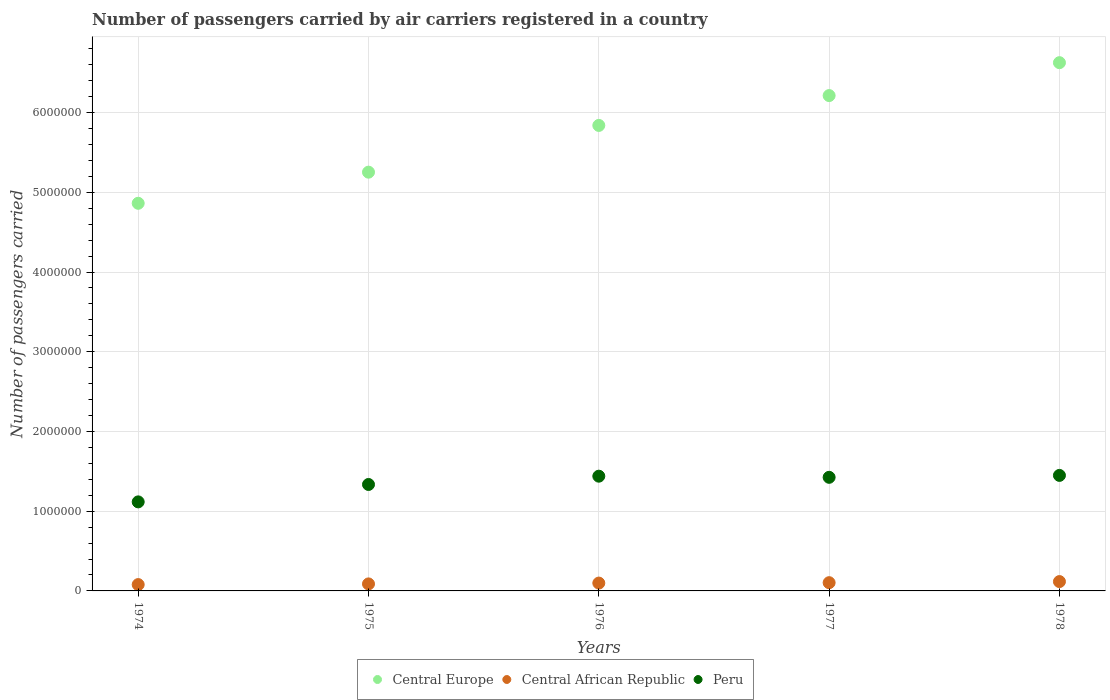How many different coloured dotlines are there?
Make the answer very short. 3. Is the number of dotlines equal to the number of legend labels?
Your response must be concise. Yes. What is the number of passengers carried by air carriers in Central Europe in 1976?
Provide a succinct answer. 5.84e+06. Across all years, what is the maximum number of passengers carried by air carriers in Central Europe?
Your answer should be compact. 6.63e+06. Across all years, what is the minimum number of passengers carried by air carriers in Central Europe?
Provide a succinct answer. 4.86e+06. In which year was the number of passengers carried by air carriers in Central African Republic maximum?
Make the answer very short. 1978. In which year was the number of passengers carried by air carriers in Peru minimum?
Provide a short and direct response. 1974. What is the total number of passengers carried by air carriers in Central African Republic in the graph?
Make the answer very short. 4.86e+05. What is the difference between the number of passengers carried by air carriers in Central Europe in 1976 and that in 1978?
Provide a short and direct response. -7.87e+05. What is the difference between the number of passengers carried by air carriers in Peru in 1975 and the number of passengers carried by air carriers in Central African Republic in 1978?
Your response must be concise. 1.22e+06. What is the average number of passengers carried by air carriers in Peru per year?
Make the answer very short. 1.35e+06. In the year 1977, what is the difference between the number of passengers carried by air carriers in Central Europe and number of passengers carried by air carriers in Peru?
Your response must be concise. 4.79e+06. What is the ratio of the number of passengers carried by air carriers in Central Europe in 1975 to that in 1978?
Ensure brevity in your answer.  0.79. Is the number of passengers carried by air carriers in Peru in 1974 less than that in 1977?
Offer a very short reply. Yes. Is the difference between the number of passengers carried by air carriers in Central Europe in 1975 and 1978 greater than the difference between the number of passengers carried by air carriers in Peru in 1975 and 1978?
Give a very brief answer. No. What is the difference between the highest and the second highest number of passengers carried by air carriers in Central Europe?
Offer a very short reply. 4.13e+05. What is the difference between the highest and the lowest number of passengers carried by air carriers in Peru?
Offer a very short reply. 3.32e+05. In how many years, is the number of passengers carried by air carriers in Central Europe greater than the average number of passengers carried by air carriers in Central Europe taken over all years?
Offer a terse response. 3. Is the sum of the number of passengers carried by air carriers in Peru in 1976 and 1978 greater than the maximum number of passengers carried by air carriers in Central Europe across all years?
Make the answer very short. No. Is it the case that in every year, the sum of the number of passengers carried by air carriers in Central Europe and number of passengers carried by air carriers in Central African Republic  is greater than the number of passengers carried by air carriers in Peru?
Your answer should be compact. Yes. Does the number of passengers carried by air carriers in Central African Republic monotonically increase over the years?
Your answer should be compact. Yes. Is the number of passengers carried by air carriers in Central Europe strictly less than the number of passengers carried by air carriers in Central African Republic over the years?
Give a very brief answer. No. How many dotlines are there?
Provide a succinct answer. 3. What is the difference between two consecutive major ticks on the Y-axis?
Your response must be concise. 1.00e+06. Are the values on the major ticks of Y-axis written in scientific E-notation?
Keep it short and to the point. No. Does the graph contain any zero values?
Your response must be concise. No. Where does the legend appear in the graph?
Provide a short and direct response. Bottom center. How many legend labels are there?
Offer a terse response. 3. What is the title of the graph?
Ensure brevity in your answer.  Number of passengers carried by air carriers registered in a country. Does "Chile" appear as one of the legend labels in the graph?
Provide a succinct answer. No. What is the label or title of the X-axis?
Your response must be concise. Years. What is the label or title of the Y-axis?
Give a very brief answer. Number of passengers carried. What is the Number of passengers carried in Central Europe in 1974?
Provide a succinct answer. 4.86e+06. What is the Number of passengers carried in Central African Republic in 1974?
Offer a very short reply. 7.95e+04. What is the Number of passengers carried in Peru in 1974?
Offer a very short reply. 1.12e+06. What is the Number of passengers carried of Central Europe in 1975?
Make the answer very short. 5.25e+06. What is the Number of passengers carried in Central African Republic in 1975?
Your answer should be very brief. 8.80e+04. What is the Number of passengers carried of Peru in 1975?
Keep it short and to the point. 1.34e+06. What is the Number of passengers carried in Central Europe in 1976?
Offer a very short reply. 5.84e+06. What is the Number of passengers carried of Central African Republic in 1976?
Provide a short and direct response. 9.84e+04. What is the Number of passengers carried in Peru in 1976?
Ensure brevity in your answer.  1.44e+06. What is the Number of passengers carried in Central Europe in 1977?
Offer a very short reply. 6.21e+06. What is the Number of passengers carried in Central African Republic in 1977?
Ensure brevity in your answer.  1.03e+05. What is the Number of passengers carried in Peru in 1977?
Offer a terse response. 1.42e+06. What is the Number of passengers carried of Central Europe in 1978?
Provide a succinct answer. 6.63e+06. What is the Number of passengers carried of Central African Republic in 1978?
Your response must be concise. 1.17e+05. What is the Number of passengers carried of Peru in 1978?
Your answer should be compact. 1.45e+06. Across all years, what is the maximum Number of passengers carried of Central Europe?
Provide a short and direct response. 6.63e+06. Across all years, what is the maximum Number of passengers carried in Central African Republic?
Your answer should be compact. 1.17e+05. Across all years, what is the maximum Number of passengers carried of Peru?
Provide a succinct answer. 1.45e+06. Across all years, what is the minimum Number of passengers carried in Central Europe?
Provide a succinct answer. 4.86e+06. Across all years, what is the minimum Number of passengers carried of Central African Republic?
Offer a terse response. 7.95e+04. Across all years, what is the minimum Number of passengers carried in Peru?
Provide a short and direct response. 1.12e+06. What is the total Number of passengers carried of Central Europe in the graph?
Your answer should be very brief. 2.88e+07. What is the total Number of passengers carried in Central African Republic in the graph?
Your response must be concise. 4.86e+05. What is the total Number of passengers carried in Peru in the graph?
Provide a short and direct response. 6.77e+06. What is the difference between the Number of passengers carried in Central Europe in 1974 and that in 1975?
Provide a short and direct response. -3.90e+05. What is the difference between the Number of passengers carried in Central African Republic in 1974 and that in 1975?
Give a very brief answer. -8500. What is the difference between the Number of passengers carried of Peru in 1974 and that in 1975?
Make the answer very short. -2.18e+05. What is the difference between the Number of passengers carried in Central Europe in 1974 and that in 1976?
Your response must be concise. -9.77e+05. What is the difference between the Number of passengers carried in Central African Republic in 1974 and that in 1976?
Provide a short and direct response. -1.89e+04. What is the difference between the Number of passengers carried of Peru in 1974 and that in 1976?
Make the answer very short. -3.22e+05. What is the difference between the Number of passengers carried in Central Europe in 1974 and that in 1977?
Offer a very short reply. -1.35e+06. What is the difference between the Number of passengers carried in Central African Republic in 1974 and that in 1977?
Provide a succinct answer. -2.39e+04. What is the difference between the Number of passengers carried of Peru in 1974 and that in 1977?
Keep it short and to the point. -3.08e+05. What is the difference between the Number of passengers carried in Central Europe in 1974 and that in 1978?
Offer a very short reply. -1.76e+06. What is the difference between the Number of passengers carried of Central African Republic in 1974 and that in 1978?
Make the answer very short. -3.77e+04. What is the difference between the Number of passengers carried of Peru in 1974 and that in 1978?
Your answer should be compact. -3.32e+05. What is the difference between the Number of passengers carried of Central Europe in 1975 and that in 1976?
Offer a terse response. -5.86e+05. What is the difference between the Number of passengers carried of Central African Republic in 1975 and that in 1976?
Make the answer very short. -1.04e+04. What is the difference between the Number of passengers carried of Peru in 1975 and that in 1976?
Keep it short and to the point. -1.04e+05. What is the difference between the Number of passengers carried in Central Europe in 1975 and that in 1977?
Provide a succinct answer. -9.61e+05. What is the difference between the Number of passengers carried of Central African Republic in 1975 and that in 1977?
Your answer should be very brief. -1.54e+04. What is the difference between the Number of passengers carried in Peru in 1975 and that in 1977?
Your answer should be compact. -8.98e+04. What is the difference between the Number of passengers carried of Central Europe in 1975 and that in 1978?
Offer a terse response. -1.37e+06. What is the difference between the Number of passengers carried in Central African Republic in 1975 and that in 1978?
Ensure brevity in your answer.  -2.92e+04. What is the difference between the Number of passengers carried of Peru in 1975 and that in 1978?
Offer a terse response. -1.14e+05. What is the difference between the Number of passengers carried in Central Europe in 1976 and that in 1977?
Provide a short and direct response. -3.74e+05. What is the difference between the Number of passengers carried in Central African Republic in 1976 and that in 1977?
Make the answer very short. -5000. What is the difference between the Number of passengers carried of Peru in 1976 and that in 1977?
Provide a succinct answer. 1.42e+04. What is the difference between the Number of passengers carried in Central Europe in 1976 and that in 1978?
Keep it short and to the point. -7.87e+05. What is the difference between the Number of passengers carried in Central African Republic in 1976 and that in 1978?
Offer a terse response. -1.88e+04. What is the difference between the Number of passengers carried in Peru in 1976 and that in 1978?
Your response must be concise. -9800. What is the difference between the Number of passengers carried in Central Europe in 1977 and that in 1978?
Ensure brevity in your answer.  -4.13e+05. What is the difference between the Number of passengers carried in Central African Republic in 1977 and that in 1978?
Your answer should be compact. -1.38e+04. What is the difference between the Number of passengers carried of Peru in 1977 and that in 1978?
Your answer should be compact. -2.40e+04. What is the difference between the Number of passengers carried of Central Europe in 1974 and the Number of passengers carried of Central African Republic in 1975?
Your answer should be very brief. 4.77e+06. What is the difference between the Number of passengers carried in Central Europe in 1974 and the Number of passengers carried in Peru in 1975?
Offer a terse response. 3.53e+06. What is the difference between the Number of passengers carried of Central African Republic in 1974 and the Number of passengers carried of Peru in 1975?
Provide a succinct answer. -1.26e+06. What is the difference between the Number of passengers carried of Central Europe in 1974 and the Number of passengers carried of Central African Republic in 1976?
Give a very brief answer. 4.76e+06. What is the difference between the Number of passengers carried in Central Europe in 1974 and the Number of passengers carried in Peru in 1976?
Provide a short and direct response. 3.42e+06. What is the difference between the Number of passengers carried in Central African Republic in 1974 and the Number of passengers carried in Peru in 1976?
Offer a terse response. -1.36e+06. What is the difference between the Number of passengers carried of Central Europe in 1974 and the Number of passengers carried of Central African Republic in 1977?
Make the answer very short. 4.76e+06. What is the difference between the Number of passengers carried in Central Europe in 1974 and the Number of passengers carried in Peru in 1977?
Offer a terse response. 3.44e+06. What is the difference between the Number of passengers carried of Central African Republic in 1974 and the Number of passengers carried of Peru in 1977?
Your response must be concise. -1.35e+06. What is the difference between the Number of passengers carried of Central Europe in 1974 and the Number of passengers carried of Central African Republic in 1978?
Provide a succinct answer. 4.75e+06. What is the difference between the Number of passengers carried of Central Europe in 1974 and the Number of passengers carried of Peru in 1978?
Your answer should be very brief. 3.41e+06. What is the difference between the Number of passengers carried in Central African Republic in 1974 and the Number of passengers carried in Peru in 1978?
Provide a succinct answer. -1.37e+06. What is the difference between the Number of passengers carried in Central Europe in 1975 and the Number of passengers carried in Central African Republic in 1976?
Provide a succinct answer. 5.15e+06. What is the difference between the Number of passengers carried of Central Europe in 1975 and the Number of passengers carried of Peru in 1976?
Offer a terse response. 3.81e+06. What is the difference between the Number of passengers carried in Central African Republic in 1975 and the Number of passengers carried in Peru in 1976?
Your answer should be compact. -1.35e+06. What is the difference between the Number of passengers carried of Central Europe in 1975 and the Number of passengers carried of Central African Republic in 1977?
Give a very brief answer. 5.15e+06. What is the difference between the Number of passengers carried of Central Europe in 1975 and the Number of passengers carried of Peru in 1977?
Offer a very short reply. 3.83e+06. What is the difference between the Number of passengers carried of Central African Republic in 1975 and the Number of passengers carried of Peru in 1977?
Give a very brief answer. -1.34e+06. What is the difference between the Number of passengers carried of Central Europe in 1975 and the Number of passengers carried of Central African Republic in 1978?
Provide a short and direct response. 5.14e+06. What is the difference between the Number of passengers carried in Central Europe in 1975 and the Number of passengers carried in Peru in 1978?
Ensure brevity in your answer.  3.80e+06. What is the difference between the Number of passengers carried in Central African Republic in 1975 and the Number of passengers carried in Peru in 1978?
Your answer should be very brief. -1.36e+06. What is the difference between the Number of passengers carried of Central Europe in 1976 and the Number of passengers carried of Central African Republic in 1977?
Give a very brief answer. 5.74e+06. What is the difference between the Number of passengers carried of Central Europe in 1976 and the Number of passengers carried of Peru in 1977?
Offer a terse response. 4.41e+06. What is the difference between the Number of passengers carried of Central African Republic in 1976 and the Number of passengers carried of Peru in 1977?
Your answer should be compact. -1.33e+06. What is the difference between the Number of passengers carried in Central Europe in 1976 and the Number of passengers carried in Central African Republic in 1978?
Provide a succinct answer. 5.72e+06. What is the difference between the Number of passengers carried in Central Europe in 1976 and the Number of passengers carried in Peru in 1978?
Provide a succinct answer. 4.39e+06. What is the difference between the Number of passengers carried in Central African Republic in 1976 and the Number of passengers carried in Peru in 1978?
Provide a succinct answer. -1.35e+06. What is the difference between the Number of passengers carried of Central Europe in 1977 and the Number of passengers carried of Central African Republic in 1978?
Ensure brevity in your answer.  6.10e+06. What is the difference between the Number of passengers carried in Central Europe in 1977 and the Number of passengers carried in Peru in 1978?
Your answer should be compact. 4.76e+06. What is the difference between the Number of passengers carried in Central African Republic in 1977 and the Number of passengers carried in Peru in 1978?
Make the answer very short. -1.35e+06. What is the average Number of passengers carried in Central Europe per year?
Make the answer very short. 5.76e+06. What is the average Number of passengers carried in Central African Republic per year?
Provide a succinct answer. 9.73e+04. What is the average Number of passengers carried in Peru per year?
Provide a short and direct response. 1.35e+06. In the year 1974, what is the difference between the Number of passengers carried in Central Europe and Number of passengers carried in Central African Republic?
Your answer should be very brief. 4.78e+06. In the year 1974, what is the difference between the Number of passengers carried in Central Europe and Number of passengers carried in Peru?
Keep it short and to the point. 3.75e+06. In the year 1974, what is the difference between the Number of passengers carried of Central African Republic and Number of passengers carried of Peru?
Your answer should be very brief. -1.04e+06. In the year 1975, what is the difference between the Number of passengers carried of Central Europe and Number of passengers carried of Central African Republic?
Provide a succinct answer. 5.16e+06. In the year 1975, what is the difference between the Number of passengers carried in Central Europe and Number of passengers carried in Peru?
Make the answer very short. 3.92e+06. In the year 1975, what is the difference between the Number of passengers carried in Central African Republic and Number of passengers carried in Peru?
Your answer should be compact. -1.25e+06. In the year 1976, what is the difference between the Number of passengers carried of Central Europe and Number of passengers carried of Central African Republic?
Offer a terse response. 5.74e+06. In the year 1976, what is the difference between the Number of passengers carried in Central Europe and Number of passengers carried in Peru?
Make the answer very short. 4.40e+06. In the year 1976, what is the difference between the Number of passengers carried in Central African Republic and Number of passengers carried in Peru?
Ensure brevity in your answer.  -1.34e+06. In the year 1977, what is the difference between the Number of passengers carried of Central Europe and Number of passengers carried of Central African Republic?
Provide a short and direct response. 6.11e+06. In the year 1977, what is the difference between the Number of passengers carried in Central Europe and Number of passengers carried in Peru?
Keep it short and to the point. 4.79e+06. In the year 1977, what is the difference between the Number of passengers carried of Central African Republic and Number of passengers carried of Peru?
Provide a short and direct response. -1.32e+06. In the year 1978, what is the difference between the Number of passengers carried in Central Europe and Number of passengers carried in Central African Republic?
Provide a succinct answer. 6.51e+06. In the year 1978, what is the difference between the Number of passengers carried of Central Europe and Number of passengers carried of Peru?
Make the answer very short. 5.18e+06. In the year 1978, what is the difference between the Number of passengers carried of Central African Republic and Number of passengers carried of Peru?
Your answer should be compact. -1.33e+06. What is the ratio of the Number of passengers carried in Central Europe in 1974 to that in 1975?
Give a very brief answer. 0.93. What is the ratio of the Number of passengers carried of Central African Republic in 1974 to that in 1975?
Keep it short and to the point. 0.9. What is the ratio of the Number of passengers carried of Peru in 1974 to that in 1975?
Keep it short and to the point. 0.84. What is the ratio of the Number of passengers carried in Central Europe in 1974 to that in 1976?
Make the answer very short. 0.83. What is the ratio of the Number of passengers carried of Central African Republic in 1974 to that in 1976?
Offer a terse response. 0.81. What is the ratio of the Number of passengers carried in Peru in 1974 to that in 1976?
Your response must be concise. 0.78. What is the ratio of the Number of passengers carried in Central Europe in 1974 to that in 1977?
Offer a very short reply. 0.78. What is the ratio of the Number of passengers carried in Central African Republic in 1974 to that in 1977?
Give a very brief answer. 0.77. What is the ratio of the Number of passengers carried in Peru in 1974 to that in 1977?
Keep it short and to the point. 0.78. What is the ratio of the Number of passengers carried of Central Europe in 1974 to that in 1978?
Provide a short and direct response. 0.73. What is the ratio of the Number of passengers carried in Central African Republic in 1974 to that in 1978?
Ensure brevity in your answer.  0.68. What is the ratio of the Number of passengers carried in Peru in 1974 to that in 1978?
Keep it short and to the point. 0.77. What is the ratio of the Number of passengers carried of Central Europe in 1975 to that in 1976?
Give a very brief answer. 0.9. What is the ratio of the Number of passengers carried of Central African Republic in 1975 to that in 1976?
Ensure brevity in your answer.  0.89. What is the ratio of the Number of passengers carried in Peru in 1975 to that in 1976?
Keep it short and to the point. 0.93. What is the ratio of the Number of passengers carried in Central Europe in 1975 to that in 1977?
Make the answer very short. 0.85. What is the ratio of the Number of passengers carried of Central African Republic in 1975 to that in 1977?
Offer a terse response. 0.85. What is the ratio of the Number of passengers carried in Peru in 1975 to that in 1977?
Make the answer very short. 0.94. What is the ratio of the Number of passengers carried of Central Europe in 1975 to that in 1978?
Keep it short and to the point. 0.79. What is the ratio of the Number of passengers carried in Central African Republic in 1975 to that in 1978?
Offer a very short reply. 0.75. What is the ratio of the Number of passengers carried of Peru in 1975 to that in 1978?
Your answer should be compact. 0.92. What is the ratio of the Number of passengers carried in Central Europe in 1976 to that in 1977?
Keep it short and to the point. 0.94. What is the ratio of the Number of passengers carried of Central African Republic in 1976 to that in 1977?
Your answer should be very brief. 0.95. What is the ratio of the Number of passengers carried of Peru in 1976 to that in 1977?
Offer a terse response. 1.01. What is the ratio of the Number of passengers carried of Central Europe in 1976 to that in 1978?
Ensure brevity in your answer.  0.88. What is the ratio of the Number of passengers carried in Central African Republic in 1976 to that in 1978?
Your response must be concise. 0.84. What is the ratio of the Number of passengers carried of Central Europe in 1977 to that in 1978?
Your response must be concise. 0.94. What is the ratio of the Number of passengers carried of Central African Republic in 1977 to that in 1978?
Ensure brevity in your answer.  0.88. What is the ratio of the Number of passengers carried of Peru in 1977 to that in 1978?
Keep it short and to the point. 0.98. What is the difference between the highest and the second highest Number of passengers carried in Central Europe?
Your answer should be very brief. 4.13e+05. What is the difference between the highest and the second highest Number of passengers carried in Central African Republic?
Provide a succinct answer. 1.38e+04. What is the difference between the highest and the second highest Number of passengers carried of Peru?
Provide a short and direct response. 9800. What is the difference between the highest and the lowest Number of passengers carried of Central Europe?
Make the answer very short. 1.76e+06. What is the difference between the highest and the lowest Number of passengers carried of Central African Republic?
Provide a short and direct response. 3.77e+04. What is the difference between the highest and the lowest Number of passengers carried of Peru?
Your answer should be compact. 3.32e+05. 